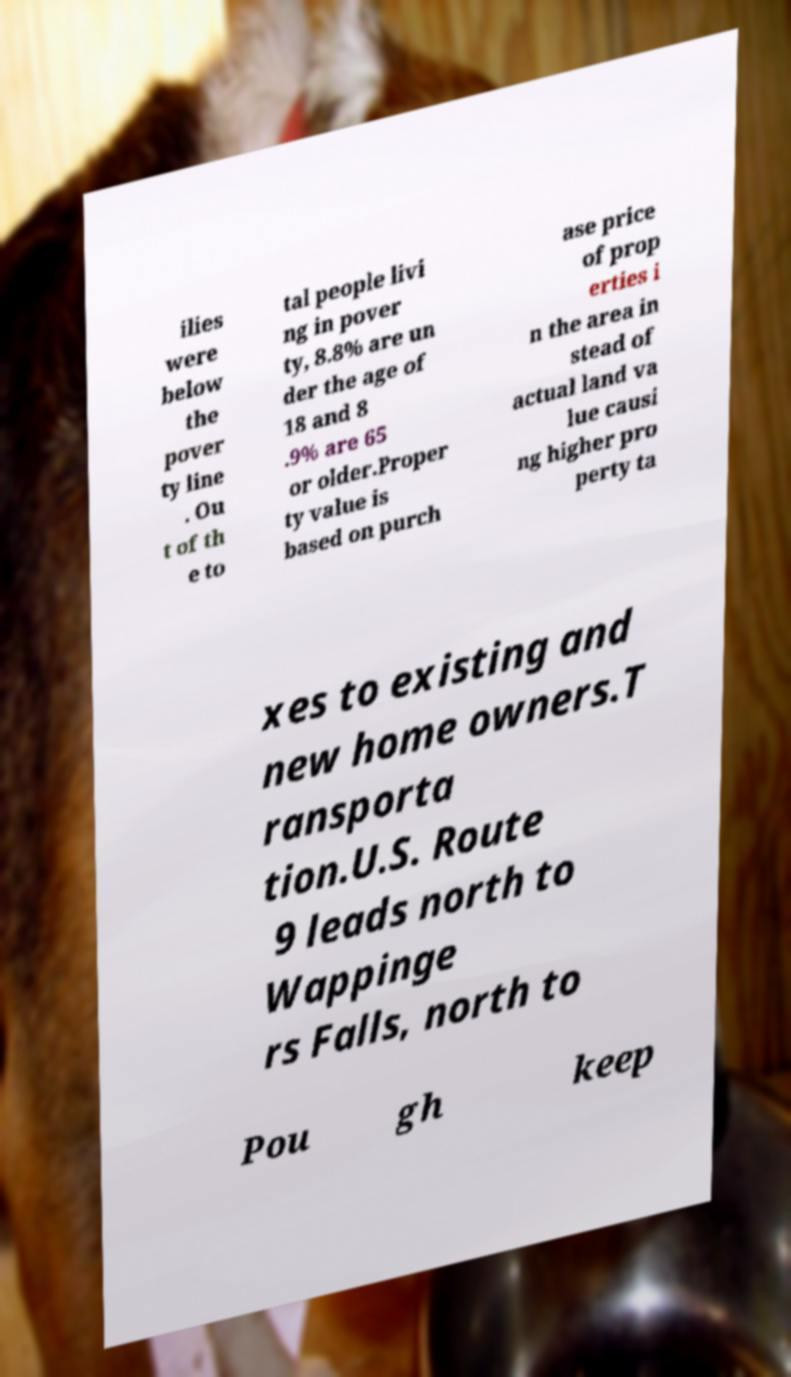Can you read and provide the text displayed in the image?This photo seems to have some interesting text. Can you extract and type it out for me? ilies were below the pover ty line . Ou t of th e to tal people livi ng in pover ty, 8.8% are un der the age of 18 and 8 .9% are 65 or older.Proper ty value is based on purch ase price of prop erties i n the area in stead of actual land va lue causi ng higher pro perty ta xes to existing and new home owners.T ransporta tion.U.S. Route 9 leads north to Wappinge rs Falls, north to Pou gh keep 